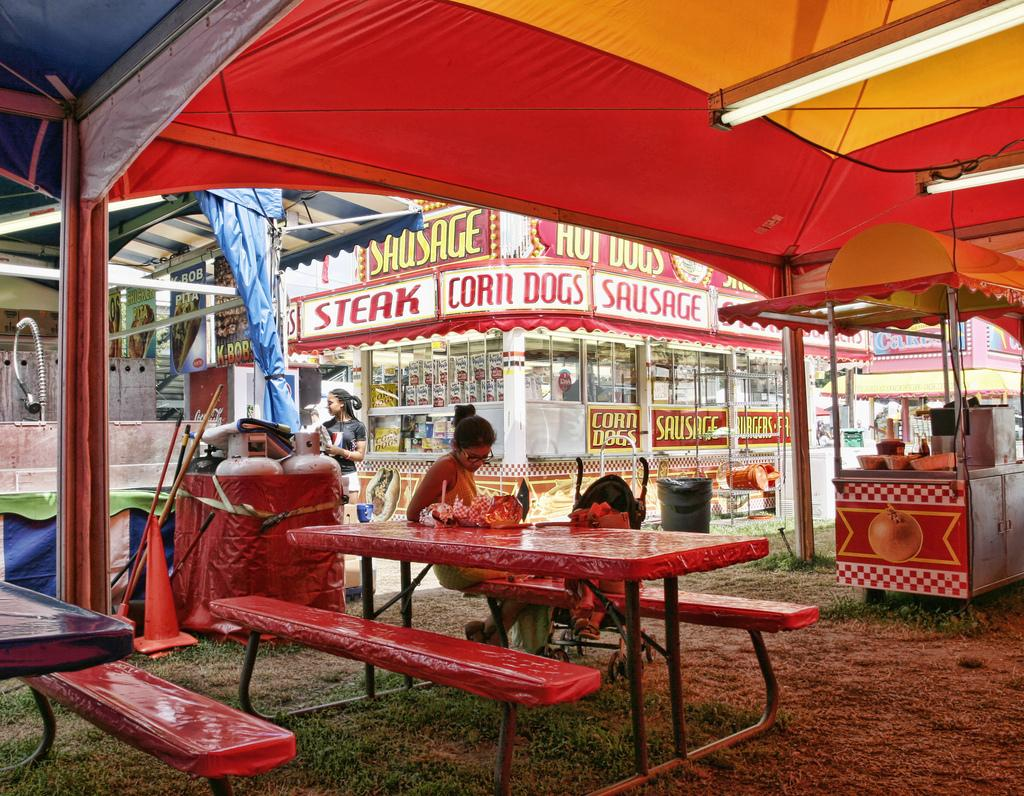What is the person in the image sitting on? The person is sitting on a red bench. What can be seen in the background of the image? There are buildings behind the person. What type of food is advertised on the hoarding in the image? The hoarding has the words "steak," "corn dogs," and "sausage" written on it. How many bikes are parked next to the person in the image? There are no bikes visible in the image. What color is the person's hair in the image? The provided facts do not mention the person's hair color, so we cannot determine it from the image. 